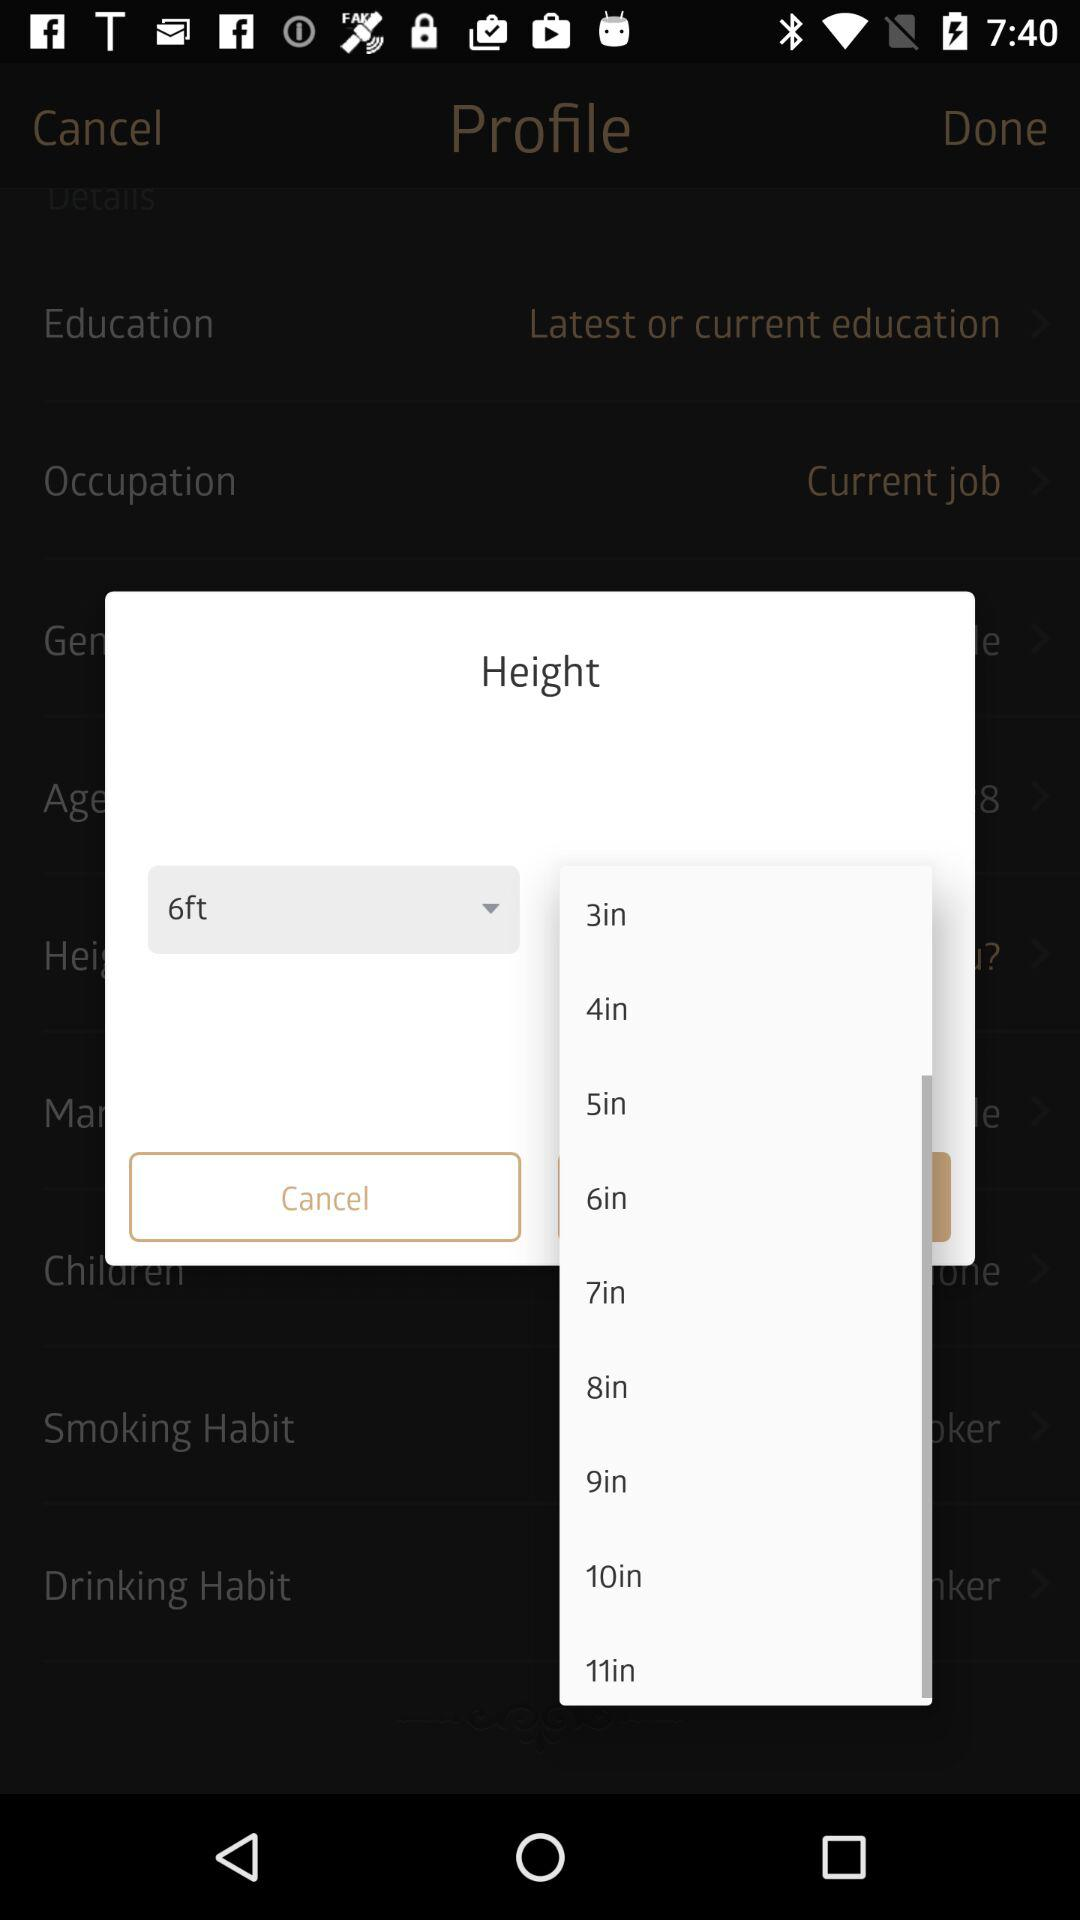Which height is selected? The selected height is 6 feet. 